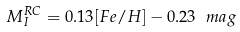<formula> <loc_0><loc_0><loc_500><loc_500>M _ { I } ^ { R C } = 0 . 1 3 [ F e / H ] - 0 . 2 3 \ m a g</formula> 